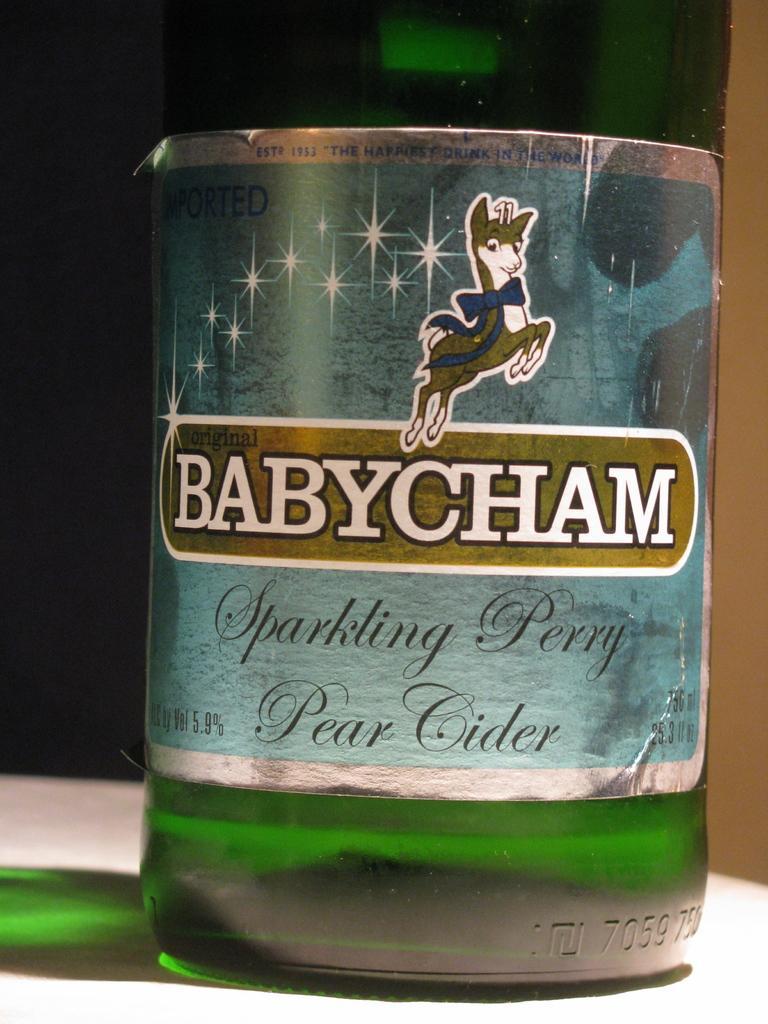In one or two sentences, can you explain what this image depicts? In the center of the image, we can see a bottle on the table. 